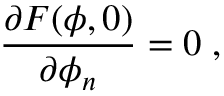<formula> <loc_0><loc_0><loc_500><loc_500>\frac { \partial F ( \phi , 0 ) } { \partial \phi _ { n } } = 0 \, ,</formula> 